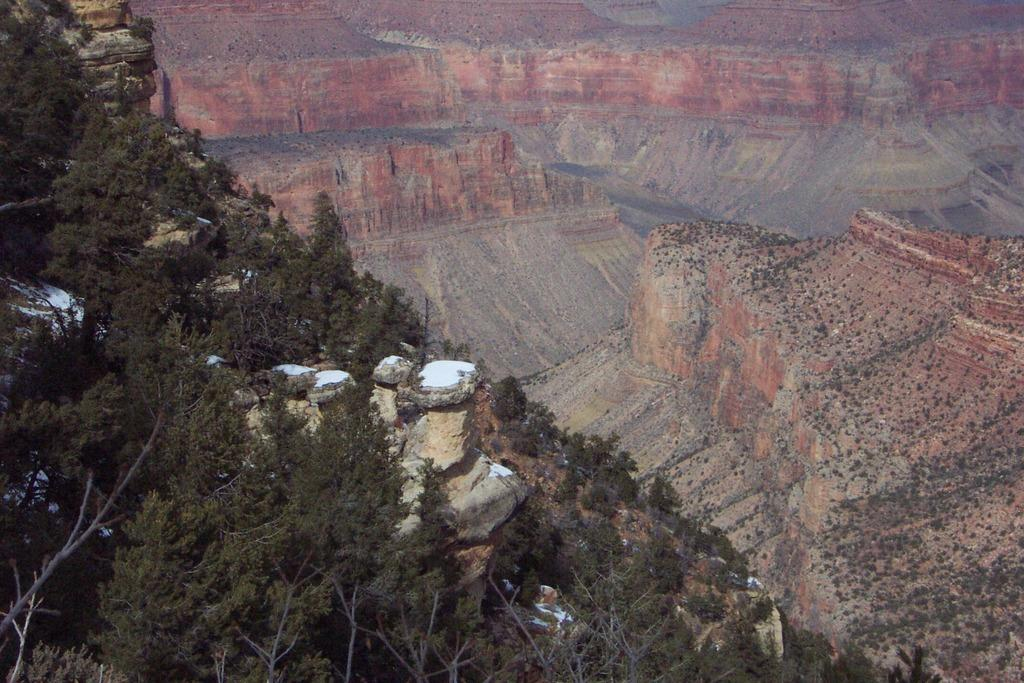What type of vegetation can be seen in the image? There are trees in the image. How many circles can be seen in the image? There are no circles present in the image. What type of furniture is visible in the image? There is no furniture visible in the image, as it only features trees. 